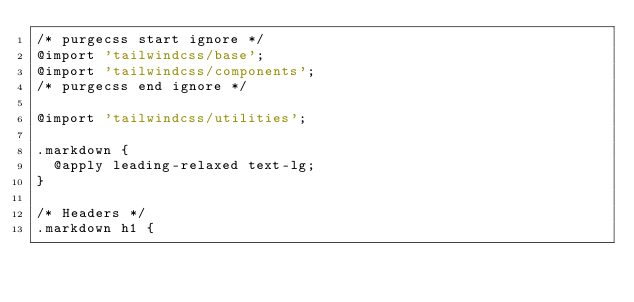<code> <loc_0><loc_0><loc_500><loc_500><_CSS_>/* purgecss start ignore */
@import 'tailwindcss/base';
@import 'tailwindcss/components';
/* purgecss end ignore */

@import 'tailwindcss/utilities';

.markdown {
  @apply leading-relaxed text-lg;
}

/* Headers */
.markdown h1 {</code> 